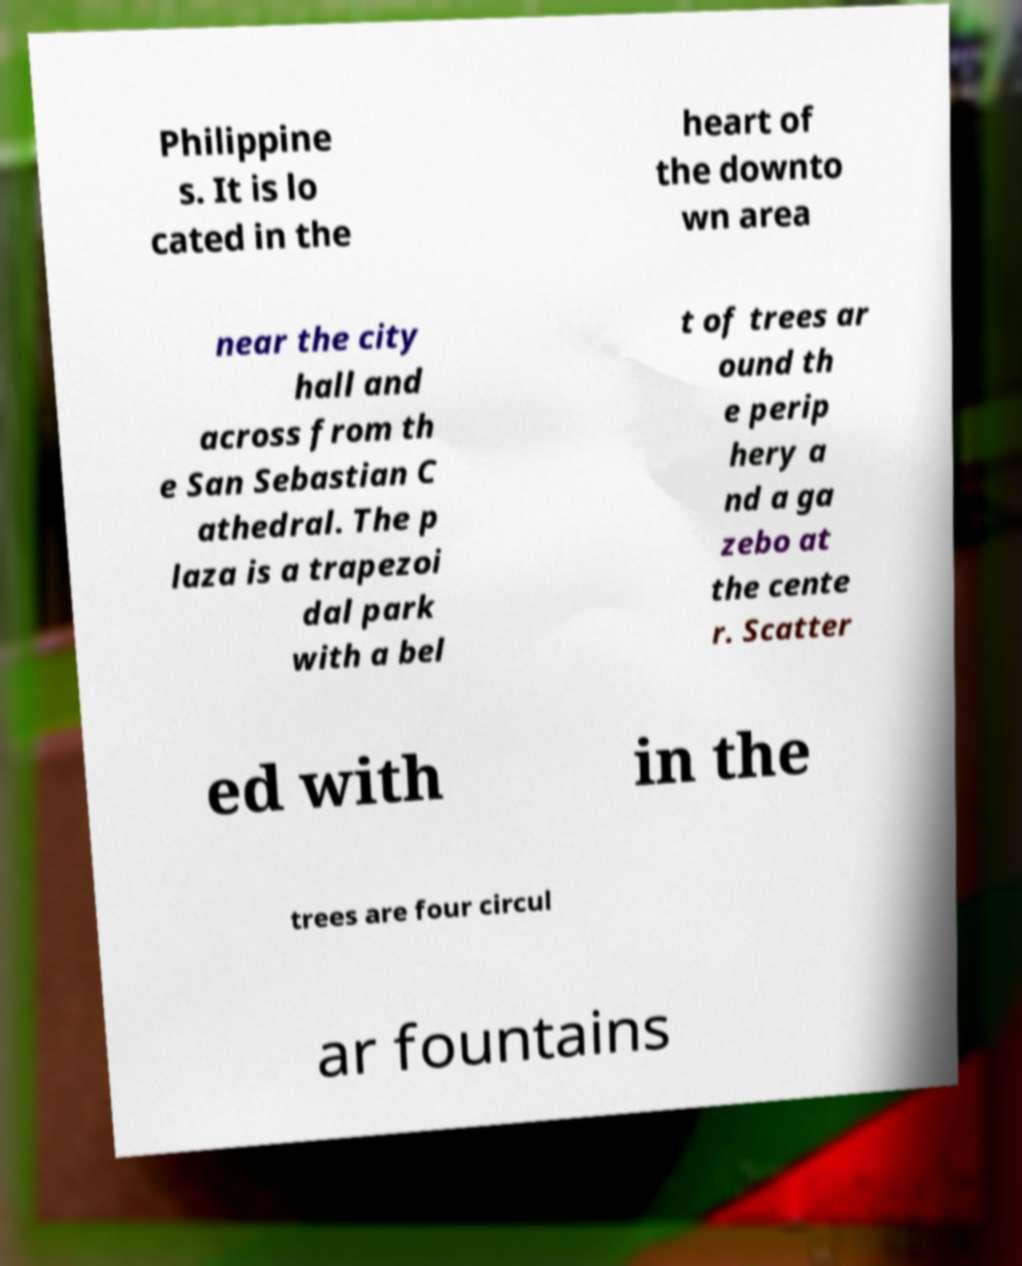For documentation purposes, I need the text within this image transcribed. Could you provide that? Philippine s. It is lo cated in the heart of the downto wn area near the city hall and across from th e San Sebastian C athedral. The p laza is a trapezoi dal park with a bel t of trees ar ound th e perip hery a nd a ga zebo at the cente r. Scatter ed with in the trees are four circul ar fountains 